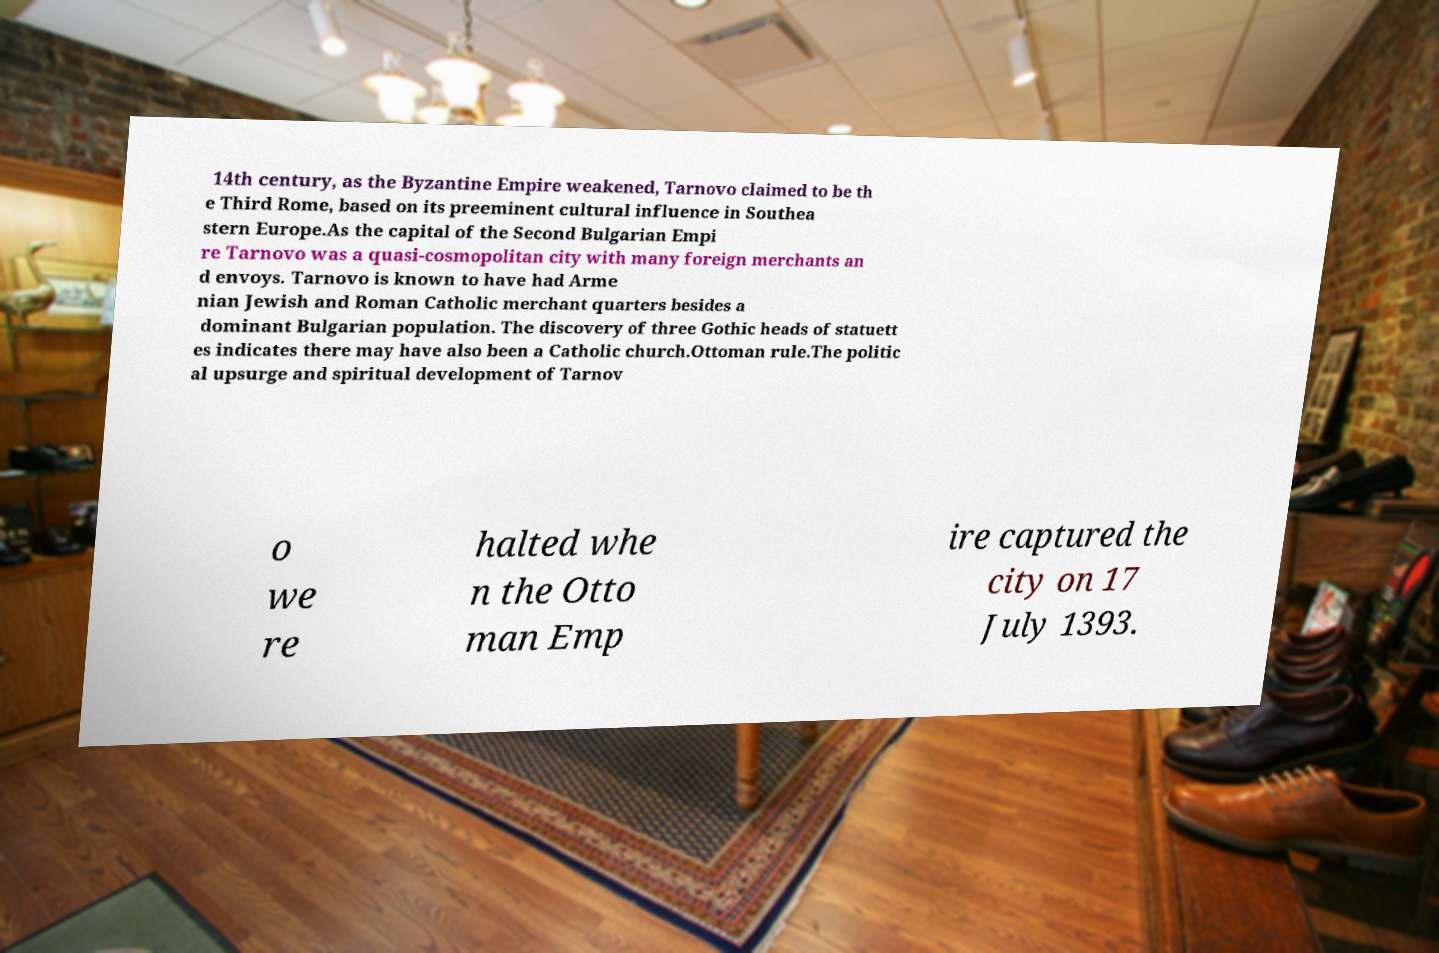Could you extract and type out the text from this image? 14th century, as the Byzantine Empire weakened, Tarnovo claimed to be th e Third Rome, based on its preeminent cultural influence in Southea stern Europe.As the capital of the Second Bulgarian Empi re Tarnovo was a quasi-cosmopolitan city with many foreign merchants an d envoys. Tarnovo is known to have had Arme nian Jewish and Roman Catholic merchant quarters besides a dominant Bulgarian population. The discovery of three Gothic heads of statuett es indicates there may have also been a Catholic church.Ottoman rule.The politic al upsurge and spiritual development of Tarnov o we re halted whe n the Otto man Emp ire captured the city on 17 July 1393. 